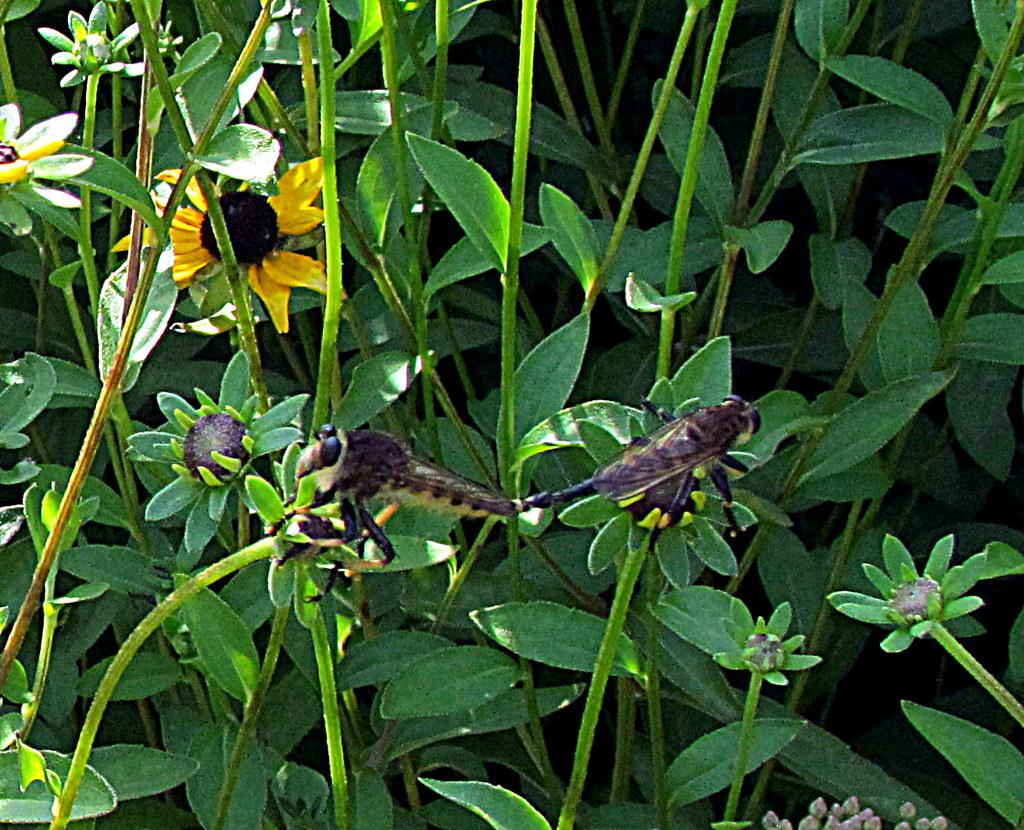What insects can be seen in the image? There are two flies in the image. What are the flies doing in the image? The flies are eating flowers. What type of vegetation is visible in the background of the image? There are plants in the background of the image, including sunflowers. What type of van can be seen in the image? There is no van present in the image. How does the yoke help the flies in the image? There is no yoke present in the image, and it would not help the flies since they are insects and not farm animals. 